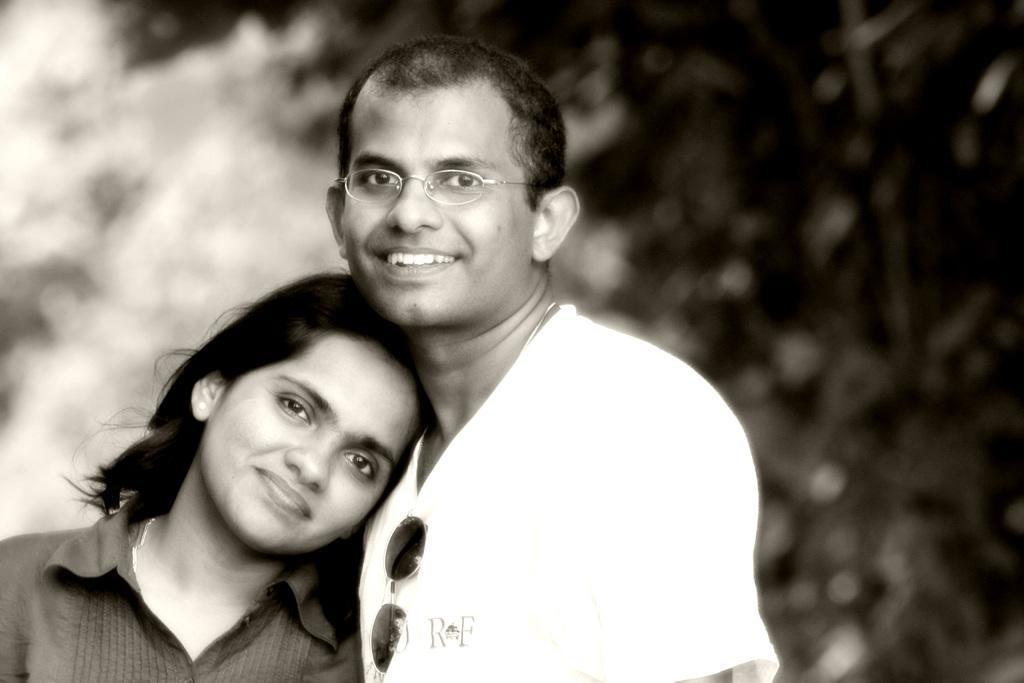Describe this image in one or two sentences. In this image I can see a woman and a man in the front. I can see both of them are smiling. I can see he is wearing a specs and on her chest I can see a goggles. I can also see this image is blurry in the background and I can see this image is black and white in colour. 